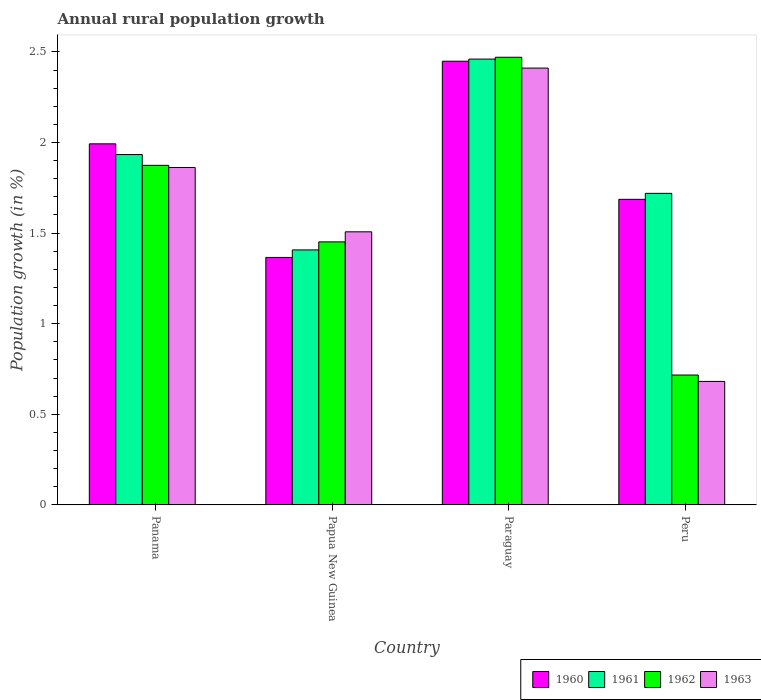Are the number of bars on each tick of the X-axis equal?
Your answer should be very brief. Yes. How many bars are there on the 1st tick from the right?
Offer a very short reply. 4. What is the label of the 2nd group of bars from the left?
Provide a succinct answer. Papua New Guinea. In how many cases, is the number of bars for a given country not equal to the number of legend labels?
Make the answer very short. 0. What is the percentage of rural population growth in 1961 in Panama?
Your response must be concise. 1.93. Across all countries, what is the maximum percentage of rural population growth in 1962?
Provide a short and direct response. 2.47. Across all countries, what is the minimum percentage of rural population growth in 1962?
Provide a succinct answer. 0.72. In which country was the percentage of rural population growth in 1960 maximum?
Make the answer very short. Paraguay. In which country was the percentage of rural population growth in 1962 minimum?
Offer a terse response. Peru. What is the total percentage of rural population growth in 1963 in the graph?
Offer a terse response. 6.46. What is the difference between the percentage of rural population growth in 1963 in Panama and that in Papua New Guinea?
Give a very brief answer. 0.35. What is the difference between the percentage of rural population growth in 1963 in Peru and the percentage of rural population growth in 1962 in Papua New Guinea?
Your answer should be compact. -0.77. What is the average percentage of rural population growth in 1963 per country?
Provide a succinct answer. 1.62. What is the difference between the percentage of rural population growth of/in 1960 and percentage of rural population growth of/in 1962 in Papua New Guinea?
Ensure brevity in your answer.  -0.09. In how many countries, is the percentage of rural population growth in 1963 greater than 0.4 %?
Your answer should be compact. 4. What is the ratio of the percentage of rural population growth in 1961 in Panama to that in Paraguay?
Offer a very short reply. 0.79. Is the difference between the percentage of rural population growth in 1960 in Panama and Paraguay greater than the difference between the percentage of rural population growth in 1962 in Panama and Paraguay?
Give a very brief answer. Yes. What is the difference between the highest and the second highest percentage of rural population growth in 1962?
Your response must be concise. -0.6. What is the difference between the highest and the lowest percentage of rural population growth in 1960?
Offer a very short reply. 1.08. In how many countries, is the percentage of rural population growth in 1963 greater than the average percentage of rural population growth in 1963 taken over all countries?
Offer a very short reply. 2. Is the sum of the percentage of rural population growth in 1961 in Paraguay and Peru greater than the maximum percentage of rural population growth in 1960 across all countries?
Ensure brevity in your answer.  Yes. Is it the case that in every country, the sum of the percentage of rural population growth in 1961 and percentage of rural population growth in 1962 is greater than the sum of percentage of rural population growth in 1963 and percentage of rural population growth in 1960?
Provide a short and direct response. No. What does the 2nd bar from the left in Peru represents?
Provide a short and direct response. 1961. How many bars are there?
Your answer should be very brief. 16. How many countries are there in the graph?
Give a very brief answer. 4. What is the difference between two consecutive major ticks on the Y-axis?
Your answer should be very brief. 0.5. Are the values on the major ticks of Y-axis written in scientific E-notation?
Give a very brief answer. No. Does the graph contain grids?
Offer a terse response. No. Where does the legend appear in the graph?
Keep it short and to the point. Bottom right. How many legend labels are there?
Offer a terse response. 4. What is the title of the graph?
Keep it short and to the point. Annual rural population growth. Does "2010" appear as one of the legend labels in the graph?
Give a very brief answer. No. What is the label or title of the Y-axis?
Keep it short and to the point. Population growth (in %). What is the Population growth (in %) in 1960 in Panama?
Make the answer very short. 1.99. What is the Population growth (in %) of 1961 in Panama?
Provide a short and direct response. 1.93. What is the Population growth (in %) in 1962 in Panama?
Your answer should be very brief. 1.87. What is the Population growth (in %) in 1963 in Panama?
Your answer should be compact. 1.86. What is the Population growth (in %) in 1960 in Papua New Guinea?
Your response must be concise. 1.37. What is the Population growth (in %) in 1961 in Papua New Guinea?
Your response must be concise. 1.41. What is the Population growth (in %) in 1962 in Papua New Guinea?
Offer a very short reply. 1.45. What is the Population growth (in %) in 1963 in Papua New Guinea?
Keep it short and to the point. 1.51. What is the Population growth (in %) in 1960 in Paraguay?
Offer a terse response. 2.45. What is the Population growth (in %) of 1961 in Paraguay?
Offer a very short reply. 2.46. What is the Population growth (in %) of 1962 in Paraguay?
Ensure brevity in your answer.  2.47. What is the Population growth (in %) in 1963 in Paraguay?
Offer a very short reply. 2.41. What is the Population growth (in %) of 1960 in Peru?
Give a very brief answer. 1.69. What is the Population growth (in %) in 1961 in Peru?
Your answer should be compact. 1.72. What is the Population growth (in %) of 1962 in Peru?
Provide a succinct answer. 0.72. What is the Population growth (in %) in 1963 in Peru?
Provide a short and direct response. 0.68. Across all countries, what is the maximum Population growth (in %) in 1960?
Your answer should be compact. 2.45. Across all countries, what is the maximum Population growth (in %) in 1961?
Keep it short and to the point. 2.46. Across all countries, what is the maximum Population growth (in %) of 1962?
Provide a short and direct response. 2.47. Across all countries, what is the maximum Population growth (in %) of 1963?
Provide a succinct answer. 2.41. Across all countries, what is the minimum Population growth (in %) of 1960?
Keep it short and to the point. 1.37. Across all countries, what is the minimum Population growth (in %) in 1961?
Make the answer very short. 1.41. Across all countries, what is the minimum Population growth (in %) of 1962?
Your answer should be compact. 0.72. Across all countries, what is the minimum Population growth (in %) of 1963?
Make the answer very short. 0.68. What is the total Population growth (in %) of 1960 in the graph?
Offer a very short reply. 7.49. What is the total Population growth (in %) in 1961 in the graph?
Your answer should be compact. 7.52. What is the total Population growth (in %) in 1962 in the graph?
Provide a succinct answer. 6.51. What is the total Population growth (in %) of 1963 in the graph?
Make the answer very short. 6.46. What is the difference between the Population growth (in %) of 1960 in Panama and that in Papua New Guinea?
Your answer should be compact. 0.63. What is the difference between the Population growth (in %) in 1961 in Panama and that in Papua New Guinea?
Give a very brief answer. 0.53. What is the difference between the Population growth (in %) in 1962 in Panama and that in Papua New Guinea?
Your answer should be very brief. 0.42. What is the difference between the Population growth (in %) in 1963 in Panama and that in Papua New Guinea?
Your answer should be compact. 0.35. What is the difference between the Population growth (in %) in 1960 in Panama and that in Paraguay?
Give a very brief answer. -0.46. What is the difference between the Population growth (in %) of 1961 in Panama and that in Paraguay?
Your answer should be compact. -0.53. What is the difference between the Population growth (in %) in 1962 in Panama and that in Paraguay?
Offer a terse response. -0.6. What is the difference between the Population growth (in %) in 1963 in Panama and that in Paraguay?
Your answer should be very brief. -0.55. What is the difference between the Population growth (in %) in 1960 in Panama and that in Peru?
Provide a succinct answer. 0.31. What is the difference between the Population growth (in %) in 1961 in Panama and that in Peru?
Your answer should be very brief. 0.21. What is the difference between the Population growth (in %) of 1962 in Panama and that in Peru?
Provide a short and direct response. 1.16. What is the difference between the Population growth (in %) in 1963 in Panama and that in Peru?
Make the answer very short. 1.18. What is the difference between the Population growth (in %) in 1960 in Papua New Guinea and that in Paraguay?
Provide a short and direct response. -1.08. What is the difference between the Population growth (in %) in 1961 in Papua New Guinea and that in Paraguay?
Provide a short and direct response. -1.05. What is the difference between the Population growth (in %) of 1962 in Papua New Guinea and that in Paraguay?
Ensure brevity in your answer.  -1.02. What is the difference between the Population growth (in %) of 1963 in Papua New Guinea and that in Paraguay?
Give a very brief answer. -0.9. What is the difference between the Population growth (in %) in 1960 in Papua New Guinea and that in Peru?
Your answer should be very brief. -0.32. What is the difference between the Population growth (in %) in 1961 in Papua New Guinea and that in Peru?
Provide a succinct answer. -0.31. What is the difference between the Population growth (in %) in 1962 in Papua New Guinea and that in Peru?
Offer a terse response. 0.73. What is the difference between the Population growth (in %) of 1963 in Papua New Guinea and that in Peru?
Your answer should be very brief. 0.83. What is the difference between the Population growth (in %) of 1960 in Paraguay and that in Peru?
Ensure brevity in your answer.  0.76. What is the difference between the Population growth (in %) in 1961 in Paraguay and that in Peru?
Offer a terse response. 0.74. What is the difference between the Population growth (in %) of 1962 in Paraguay and that in Peru?
Your response must be concise. 1.75. What is the difference between the Population growth (in %) in 1963 in Paraguay and that in Peru?
Keep it short and to the point. 1.73. What is the difference between the Population growth (in %) of 1960 in Panama and the Population growth (in %) of 1961 in Papua New Guinea?
Your answer should be very brief. 0.59. What is the difference between the Population growth (in %) of 1960 in Panama and the Population growth (in %) of 1962 in Papua New Guinea?
Your answer should be compact. 0.54. What is the difference between the Population growth (in %) of 1960 in Panama and the Population growth (in %) of 1963 in Papua New Guinea?
Provide a succinct answer. 0.49. What is the difference between the Population growth (in %) in 1961 in Panama and the Population growth (in %) in 1962 in Papua New Guinea?
Give a very brief answer. 0.48. What is the difference between the Population growth (in %) of 1961 in Panama and the Population growth (in %) of 1963 in Papua New Guinea?
Offer a terse response. 0.43. What is the difference between the Population growth (in %) of 1962 in Panama and the Population growth (in %) of 1963 in Papua New Guinea?
Provide a succinct answer. 0.37. What is the difference between the Population growth (in %) of 1960 in Panama and the Population growth (in %) of 1961 in Paraguay?
Provide a succinct answer. -0.47. What is the difference between the Population growth (in %) of 1960 in Panama and the Population growth (in %) of 1962 in Paraguay?
Provide a succinct answer. -0.48. What is the difference between the Population growth (in %) of 1960 in Panama and the Population growth (in %) of 1963 in Paraguay?
Offer a terse response. -0.42. What is the difference between the Population growth (in %) in 1961 in Panama and the Population growth (in %) in 1962 in Paraguay?
Give a very brief answer. -0.54. What is the difference between the Population growth (in %) of 1961 in Panama and the Population growth (in %) of 1963 in Paraguay?
Your answer should be compact. -0.48. What is the difference between the Population growth (in %) of 1962 in Panama and the Population growth (in %) of 1963 in Paraguay?
Ensure brevity in your answer.  -0.54. What is the difference between the Population growth (in %) of 1960 in Panama and the Population growth (in %) of 1961 in Peru?
Offer a very short reply. 0.27. What is the difference between the Population growth (in %) in 1960 in Panama and the Population growth (in %) in 1962 in Peru?
Keep it short and to the point. 1.28. What is the difference between the Population growth (in %) of 1960 in Panama and the Population growth (in %) of 1963 in Peru?
Make the answer very short. 1.31. What is the difference between the Population growth (in %) in 1961 in Panama and the Population growth (in %) in 1962 in Peru?
Keep it short and to the point. 1.22. What is the difference between the Population growth (in %) of 1961 in Panama and the Population growth (in %) of 1963 in Peru?
Provide a succinct answer. 1.25. What is the difference between the Population growth (in %) in 1962 in Panama and the Population growth (in %) in 1963 in Peru?
Offer a very short reply. 1.19. What is the difference between the Population growth (in %) of 1960 in Papua New Guinea and the Population growth (in %) of 1961 in Paraguay?
Provide a succinct answer. -1.09. What is the difference between the Population growth (in %) of 1960 in Papua New Guinea and the Population growth (in %) of 1962 in Paraguay?
Provide a short and direct response. -1.1. What is the difference between the Population growth (in %) of 1960 in Papua New Guinea and the Population growth (in %) of 1963 in Paraguay?
Your response must be concise. -1.04. What is the difference between the Population growth (in %) in 1961 in Papua New Guinea and the Population growth (in %) in 1962 in Paraguay?
Your response must be concise. -1.06. What is the difference between the Population growth (in %) in 1961 in Papua New Guinea and the Population growth (in %) in 1963 in Paraguay?
Ensure brevity in your answer.  -1. What is the difference between the Population growth (in %) in 1962 in Papua New Guinea and the Population growth (in %) in 1963 in Paraguay?
Your answer should be compact. -0.96. What is the difference between the Population growth (in %) in 1960 in Papua New Guinea and the Population growth (in %) in 1961 in Peru?
Give a very brief answer. -0.35. What is the difference between the Population growth (in %) of 1960 in Papua New Guinea and the Population growth (in %) of 1962 in Peru?
Your answer should be compact. 0.65. What is the difference between the Population growth (in %) in 1960 in Papua New Guinea and the Population growth (in %) in 1963 in Peru?
Keep it short and to the point. 0.68. What is the difference between the Population growth (in %) in 1961 in Papua New Guinea and the Population growth (in %) in 1962 in Peru?
Keep it short and to the point. 0.69. What is the difference between the Population growth (in %) of 1961 in Papua New Guinea and the Population growth (in %) of 1963 in Peru?
Offer a terse response. 0.73. What is the difference between the Population growth (in %) in 1962 in Papua New Guinea and the Population growth (in %) in 1963 in Peru?
Keep it short and to the point. 0.77. What is the difference between the Population growth (in %) of 1960 in Paraguay and the Population growth (in %) of 1961 in Peru?
Give a very brief answer. 0.73. What is the difference between the Population growth (in %) in 1960 in Paraguay and the Population growth (in %) in 1962 in Peru?
Your answer should be very brief. 1.73. What is the difference between the Population growth (in %) of 1960 in Paraguay and the Population growth (in %) of 1963 in Peru?
Keep it short and to the point. 1.77. What is the difference between the Population growth (in %) of 1961 in Paraguay and the Population growth (in %) of 1962 in Peru?
Your answer should be compact. 1.74. What is the difference between the Population growth (in %) in 1961 in Paraguay and the Population growth (in %) in 1963 in Peru?
Offer a terse response. 1.78. What is the difference between the Population growth (in %) of 1962 in Paraguay and the Population growth (in %) of 1963 in Peru?
Your response must be concise. 1.79. What is the average Population growth (in %) of 1960 per country?
Give a very brief answer. 1.87. What is the average Population growth (in %) in 1961 per country?
Offer a terse response. 1.88. What is the average Population growth (in %) of 1962 per country?
Offer a very short reply. 1.63. What is the average Population growth (in %) of 1963 per country?
Make the answer very short. 1.62. What is the difference between the Population growth (in %) of 1960 and Population growth (in %) of 1961 in Panama?
Make the answer very short. 0.06. What is the difference between the Population growth (in %) in 1960 and Population growth (in %) in 1962 in Panama?
Ensure brevity in your answer.  0.12. What is the difference between the Population growth (in %) in 1960 and Population growth (in %) in 1963 in Panama?
Give a very brief answer. 0.13. What is the difference between the Population growth (in %) of 1961 and Population growth (in %) of 1962 in Panama?
Offer a very short reply. 0.06. What is the difference between the Population growth (in %) in 1961 and Population growth (in %) in 1963 in Panama?
Provide a succinct answer. 0.07. What is the difference between the Population growth (in %) of 1962 and Population growth (in %) of 1963 in Panama?
Offer a terse response. 0.01. What is the difference between the Population growth (in %) in 1960 and Population growth (in %) in 1961 in Papua New Guinea?
Give a very brief answer. -0.04. What is the difference between the Population growth (in %) of 1960 and Population growth (in %) of 1962 in Papua New Guinea?
Your answer should be very brief. -0.09. What is the difference between the Population growth (in %) in 1960 and Population growth (in %) in 1963 in Papua New Guinea?
Offer a terse response. -0.14. What is the difference between the Population growth (in %) in 1961 and Population growth (in %) in 1962 in Papua New Guinea?
Make the answer very short. -0.04. What is the difference between the Population growth (in %) in 1961 and Population growth (in %) in 1963 in Papua New Guinea?
Provide a succinct answer. -0.1. What is the difference between the Population growth (in %) in 1962 and Population growth (in %) in 1963 in Papua New Guinea?
Provide a succinct answer. -0.06. What is the difference between the Population growth (in %) of 1960 and Population growth (in %) of 1961 in Paraguay?
Keep it short and to the point. -0.01. What is the difference between the Population growth (in %) of 1960 and Population growth (in %) of 1962 in Paraguay?
Provide a succinct answer. -0.02. What is the difference between the Population growth (in %) of 1960 and Population growth (in %) of 1963 in Paraguay?
Your answer should be very brief. 0.04. What is the difference between the Population growth (in %) of 1961 and Population growth (in %) of 1962 in Paraguay?
Offer a very short reply. -0.01. What is the difference between the Population growth (in %) of 1961 and Population growth (in %) of 1963 in Paraguay?
Provide a short and direct response. 0.05. What is the difference between the Population growth (in %) of 1962 and Population growth (in %) of 1963 in Paraguay?
Keep it short and to the point. 0.06. What is the difference between the Population growth (in %) of 1960 and Population growth (in %) of 1961 in Peru?
Offer a very short reply. -0.03. What is the difference between the Population growth (in %) in 1960 and Population growth (in %) in 1962 in Peru?
Provide a succinct answer. 0.97. What is the difference between the Population growth (in %) of 1960 and Population growth (in %) of 1963 in Peru?
Provide a succinct answer. 1. What is the difference between the Population growth (in %) in 1961 and Population growth (in %) in 1962 in Peru?
Offer a terse response. 1. What is the difference between the Population growth (in %) of 1961 and Population growth (in %) of 1963 in Peru?
Your response must be concise. 1.04. What is the difference between the Population growth (in %) in 1962 and Population growth (in %) in 1963 in Peru?
Offer a very short reply. 0.04. What is the ratio of the Population growth (in %) of 1960 in Panama to that in Papua New Guinea?
Keep it short and to the point. 1.46. What is the ratio of the Population growth (in %) of 1961 in Panama to that in Papua New Guinea?
Your response must be concise. 1.37. What is the ratio of the Population growth (in %) in 1962 in Panama to that in Papua New Guinea?
Give a very brief answer. 1.29. What is the ratio of the Population growth (in %) in 1963 in Panama to that in Papua New Guinea?
Make the answer very short. 1.24. What is the ratio of the Population growth (in %) in 1960 in Panama to that in Paraguay?
Make the answer very short. 0.81. What is the ratio of the Population growth (in %) in 1961 in Panama to that in Paraguay?
Your response must be concise. 0.79. What is the ratio of the Population growth (in %) of 1962 in Panama to that in Paraguay?
Provide a succinct answer. 0.76. What is the ratio of the Population growth (in %) in 1963 in Panama to that in Paraguay?
Keep it short and to the point. 0.77. What is the ratio of the Population growth (in %) in 1960 in Panama to that in Peru?
Provide a succinct answer. 1.18. What is the ratio of the Population growth (in %) of 1961 in Panama to that in Peru?
Ensure brevity in your answer.  1.12. What is the ratio of the Population growth (in %) of 1962 in Panama to that in Peru?
Ensure brevity in your answer.  2.61. What is the ratio of the Population growth (in %) in 1963 in Panama to that in Peru?
Your answer should be compact. 2.73. What is the ratio of the Population growth (in %) of 1960 in Papua New Guinea to that in Paraguay?
Provide a succinct answer. 0.56. What is the ratio of the Population growth (in %) in 1961 in Papua New Guinea to that in Paraguay?
Your response must be concise. 0.57. What is the ratio of the Population growth (in %) of 1962 in Papua New Guinea to that in Paraguay?
Your response must be concise. 0.59. What is the ratio of the Population growth (in %) of 1963 in Papua New Guinea to that in Paraguay?
Offer a terse response. 0.63. What is the ratio of the Population growth (in %) in 1960 in Papua New Guinea to that in Peru?
Keep it short and to the point. 0.81. What is the ratio of the Population growth (in %) of 1961 in Papua New Guinea to that in Peru?
Provide a short and direct response. 0.82. What is the ratio of the Population growth (in %) in 1962 in Papua New Guinea to that in Peru?
Provide a succinct answer. 2.02. What is the ratio of the Population growth (in %) in 1963 in Papua New Guinea to that in Peru?
Your response must be concise. 2.21. What is the ratio of the Population growth (in %) in 1960 in Paraguay to that in Peru?
Your response must be concise. 1.45. What is the ratio of the Population growth (in %) of 1961 in Paraguay to that in Peru?
Give a very brief answer. 1.43. What is the ratio of the Population growth (in %) in 1962 in Paraguay to that in Peru?
Your answer should be very brief. 3.45. What is the ratio of the Population growth (in %) of 1963 in Paraguay to that in Peru?
Offer a terse response. 3.54. What is the difference between the highest and the second highest Population growth (in %) in 1960?
Provide a succinct answer. 0.46. What is the difference between the highest and the second highest Population growth (in %) in 1961?
Provide a succinct answer. 0.53. What is the difference between the highest and the second highest Population growth (in %) in 1962?
Your answer should be very brief. 0.6. What is the difference between the highest and the second highest Population growth (in %) in 1963?
Your answer should be compact. 0.55. What is the difference between the highest and the lowest Population growth (in %) in 1960?
Ensure brevity in your answer.  1.08. What is the difference between the highest and the lowest Population growth (in %) in 1961?
Make the answer very short. 1.05. What is the difference between the highest and the lowest Population growth (in %) in 1962?
Offer a terse response. 1.75. What is the difference between the highest and the lowest Population growth (in %) of 1963?
Offer a very short reply. 1.73. 